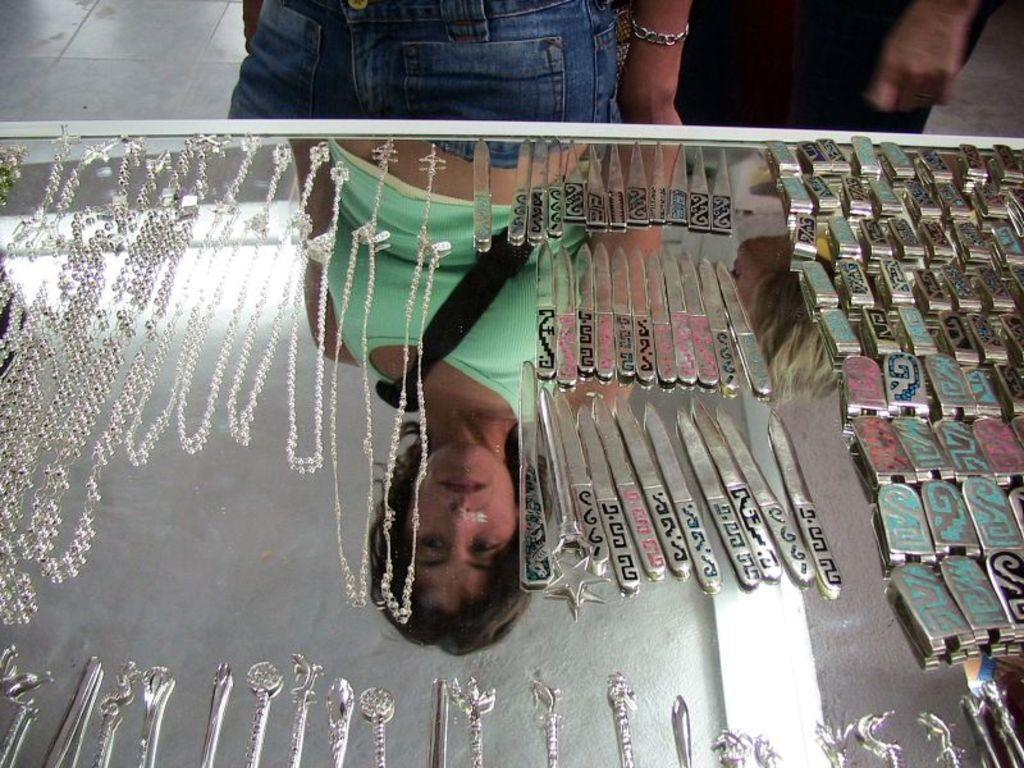How many people are in the image? There are two persons standing in the image. What can be seen attached to the persons in the image? Chains are visible in the image. What else is present on the table besides the chains? There are other things on the table in the image. What type of hydrant is present on the table in the image? There is no hydrant present on the table in the image. What work-related tasks are the persons in the image performing? The provided facts do not give us any information about the persons' work or tasks they might be performing. 